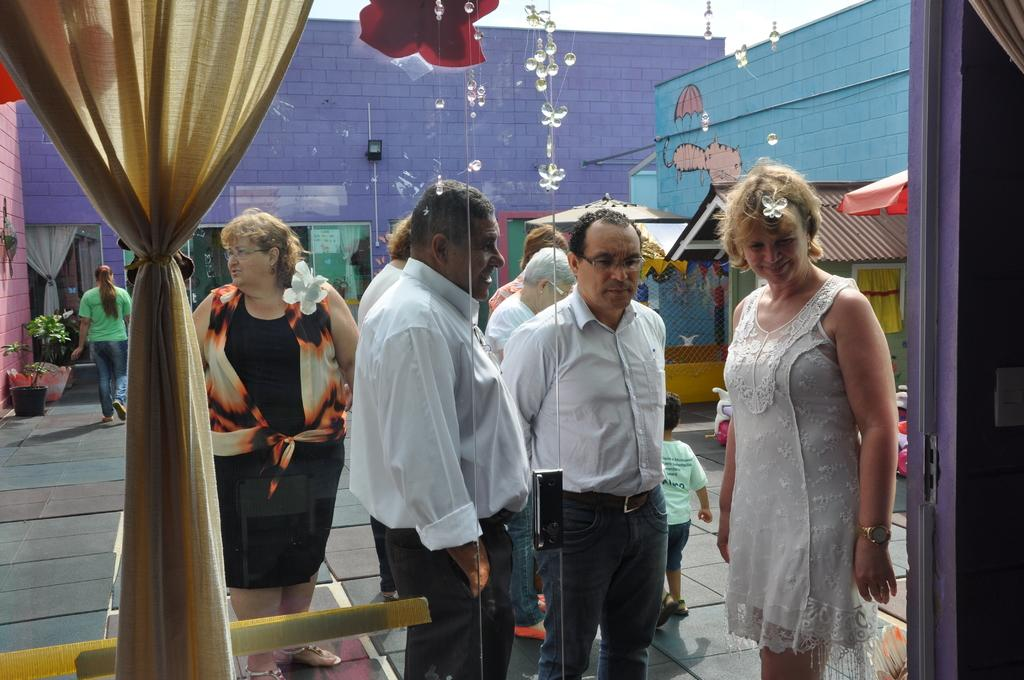What are the people in the image doing? The people in the image are standing on the floor. What can be seen on the right side of the image? There is a wall on the right side of the image. What is present on the left side of the image? There is a curtain on the left side of the image. What type of structures can be seen in the background of the image? There are houses visible in the background of the image. What type of ink is being used by the people in the image? There is no ink or reading activity present in the image; the people are simply standing on the floor. 